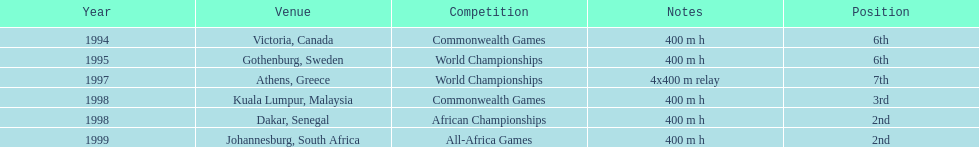What venue came before gothenburg, sweden? Victoria, Canada. 